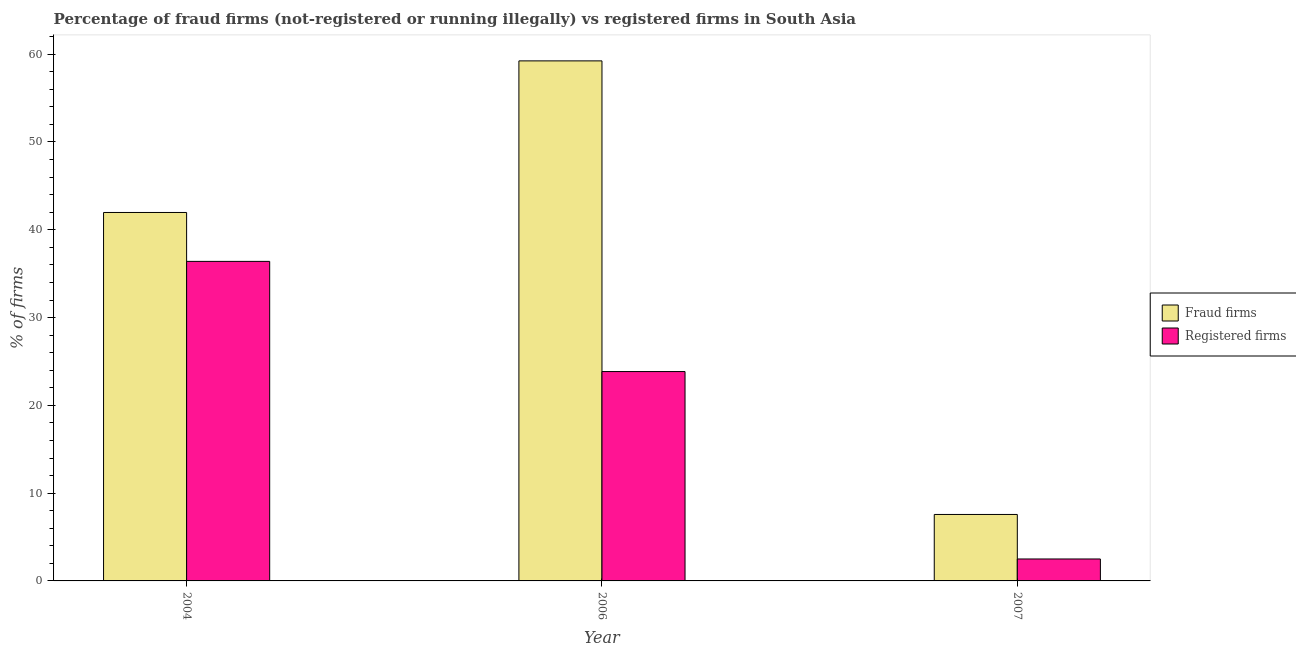Are the number of bars on each tick of the X-axis equal?
Provide a succinct answer. Yes. What is the label of the 1st group of bars from the left?
Offer a very short reply. 2004. In how many cases, is the number of bars for a given year not equal to the number of legend labels?
Provide a short and direct response. 0. What is the percentage of fraud firms in 2004?
Your response must be concise. 41.97. Across all years, what is the maximum percentage of fraud firms?
Ensure brevity in your answer.  59.24. Across all years, what is the minimum percentage of fraud firms?
Make the answer very short. 7.57. In which year was the percentage of registered firms minimum?
Ensure brevity in your answer.  2007. What is the total percentage of registered firms in the graph?
Give a very brief answer. 62.75. What is the difference between the percentage of fraud firms in 2006 and that in 2007?
Your answer should be compact. 51.67. What is the difference between the percentage of registered firms in 2006 and the percentage of fraud firms in 2004?
Offer a very short reply. -12.55. What is the average percentage of registered firms per year?
Provide a succinct answer. 20.92. What is the ratio of the percentage of fraud firms in 2006 to that in 2007?
Provide a succinct answer. 7.83. Is the percentage of fraud firms in 2006 less than that in 2007?
Your response must be concise. No. What is the difference between the highest and the second highest percentage of registered firms?
Keep it short and to the point. 12.55. What is the difference between the highest and the lowest percentage of registered firms?
Your answer should be very brief. 33.9. In how many years, is the percentage of fraud firms greater than the average percentage of fraud firms taken over all years?
Provide a short and direct response. 2. What does the 1st bar from the left in 2004 represents?
Offer a very short reply. Fraud firms. What does the 1st bar from the right in 2006 represents?
Your response must be concise. Registered firms. Are all the bars in the graph horizontal?
Offer a very short reply. No. What is the difference between two consecutive major ticks on the Y-axis?
Make the answer very short. 10. Are the values on the major ticks of Y-axis written in scientific E-notation?
Your answer should be very brief. No. Where does the legend appear in the graph?
Offer a very short reply. Center right. What is the title of the graph?
Your answer should be compact. Percentage of fraud firms (not-registered or running illegally) vs registered firms in South Asia. Does "2012 US$" appear as one of the legend labels in the graph?
Your answer should be compact. No. What is the label or title of the Y-axis?
Make the answer very short. % of firms. What is the % of firms in Fraud firms in 2004?
Your response must be concise. 41.97. What is the % of firms of Registered firms in 2004?
Offer a terse response. 36.4. What is the % of firms of Fraud firms in 2006?
Give a very brief answer. 59.24. What is the % of firms of Registered firms in 2006?
Your answer should be compact. 23.85. What is the % of firms in Fraud firms in 2007?
Offer a very short reply. 7.57. What is the % of firms of Registered firms in 2007?
Give a very brief answer. 2.5. Across all years, what is the maximum % of firms of Fraud firms?
Your answer should be very brief. 59.24. Across all years, what is the maximum % of firms of Registered firms?
Give a very brief answer. 36.4. Across all years, what is the minimum % of firms of Fraud firms?
Ensure brevity in your answer.  7.57. What is the total % of firms in Fraud firms in the graph?
Provide a succinct answer. 108.78. What is the total % of firms of Registered firms in the graph?
Offer a very short reply. 62.75. What is the difference between the % of firms of Fraud firms in 2004 and that in 2006?
Your answer should be very brief. -17.27. What is the difference between the % of firms in Registered firms in 2004 and that in 2006?
Your answer should be compact. 12.55. What is the difference between the % of firms of Fraud firms in 2004 and that in 2007?
Keep it short and to the point. 34.4. What is the difference between the % of firms of Registered firms in 2004 and that in 2007?
Your answer should be compact. 33.9. What is the difference between the % of firms of Fraud firms in 2006 and that in 2007?
Make the answer very short. 51.67. What is the difference between the % of firms of Registered firms in 2006 and that in 2007?
Your response must be concise. 21.35. What is the difference between the % of firms in Fraud firms in 2004 and the % of firms in Registered firms in 2006?
Keep it short and to the point. 18.12. What is the difference between the % of firms of Fraud firms in 2004 and the % of firms of Registered firms in 2007?
Keep it short and to the point. 39.47. What is the difference between the % of firms of Fraud firms in 2006 and the % of firms of Registered firms in 2007?
Keep it short and to the point. 56.74. What is the average % of firms in Fraud firms per year?
Your answer should be very brief. 36.26. What is the average % of firms in Registered firms per year?
Give a very brief answer. 20.92. In the year 2004, what is the difference between the % of firms in Fraud firms and % of firms in Registered firms?
Your response must be concise. 5.57. In the year 2006, what is the difference between the % of firms of Fraud firms and % of firms of Registered firms?
Provide a succinct answer. 35.39. In the year 2007, what is the difference between the % of firms of Fraud firms and % of firms of Registered firms?
Provide a short and direct response. 5.07. What is the ratio of the % of firms in Fraud firms in 2004 to that in 2006?
Your answer should be very brief. 0.71. What is the ratio of the % of firms of Registered firms in 2004 to that in 2006?
Keep it short and to the point. 1.53. What is the ratio of the % of firms of Fraud firms in 2004 to that in 2007?
Offer a very short reply. 5.54. What is the ratio of the % of firms in Registered firms in 2004 to that in 2007?
Make the answer very short. 14.56. What is the ratio of the % of firms in Fraud firms in 2006 to that in 2007?
Ensure brevity in your answer.  7.83. What is the ratio of the % of firms of Registered firms in 2006 to that in 2007?
Your answer should be very brief. 9.54. What is the difference between the highest and the second highest % of firms of Fraud firms?
Your answer should be very brief. 17.27. What is the difference between the highest and the second highest % of firms in Registered firms?
Keep it short and to the point. 12.55. What is the difference between the highest and the lowest % of firms in Fraud firms?
Offer a very short reply. 51.67. What is the difference between the highest and the lowest % of firms of Registered firms?
Provide a short and direct response. 33.9. 